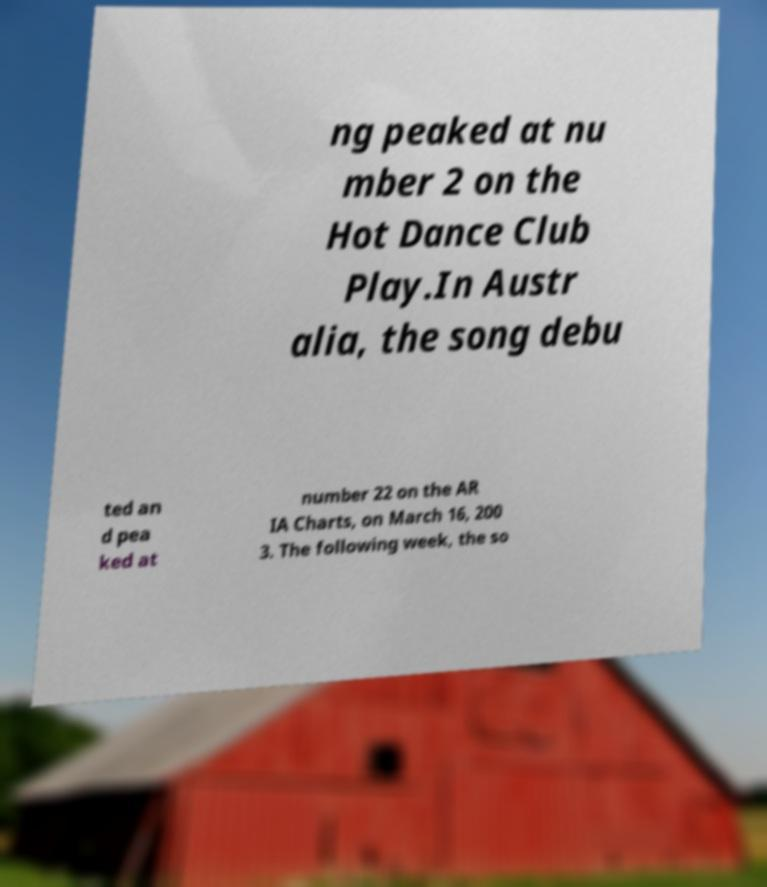I need the written content from this picture converted into text. Can you do that? ng peaked at nu mber 2 on the Hot Dance Club Play.In Austr alia, the song debu ted an d pea ked at number 22 on the AR IA Charts, on March 16, 200 3. The following week, the so 